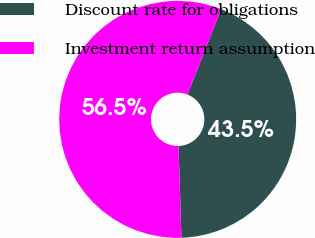Convert chart. <chart><loc_0><loc_0><loc_500><loc_500><pie_chart><fcel>Discount rate for obligations<fcel>Investment return assumption<nl><fcel>43.52%<fcel>56.48%<nl></chart> 